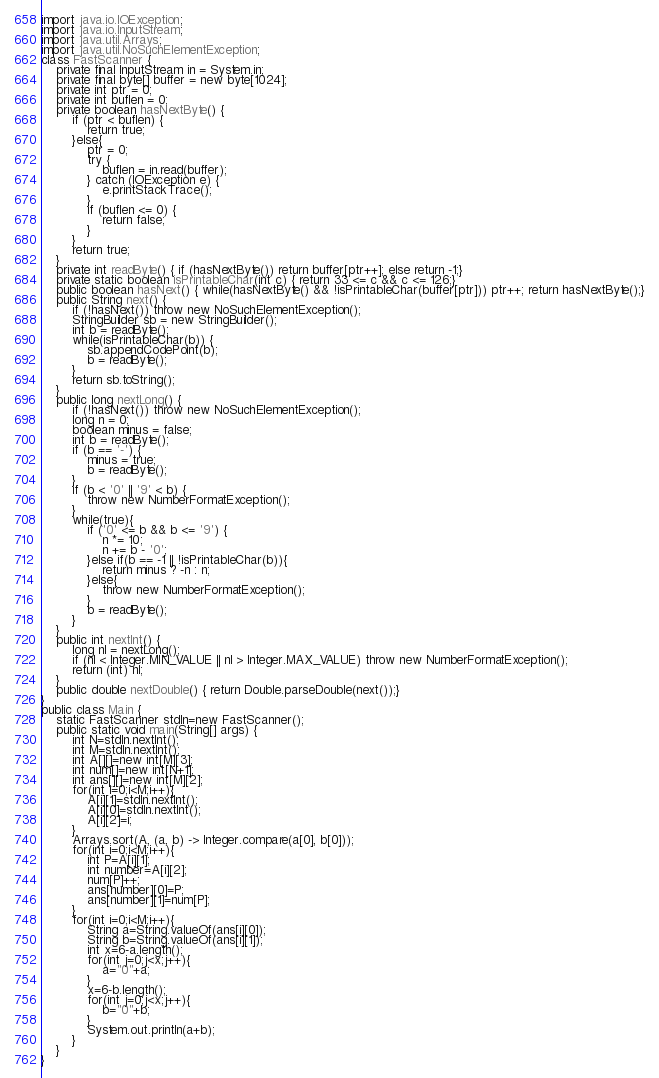<code> <loc_0><loc_0><loc_500><loc_500><_Java_>import java.io.IOException;
import java.io.InputStream;
import java.util.Arrays;
import java.util.NoSuchElementException;
class FastScanner {
    private final InputStream in = System.in;
    private final byte[] buffer = new byte[1024];
    private int ptr = 0;
    private int buflen = 0;
    private boolean hasNextByte() {
        if (ptr < buflen) {
            return true;
        }else{
            ptr = 0;
            try {
                buflen = in.read(buffer);
            } catch (IOException e) {
                e.printStackTrace();
            }
            if (buflen <= 0) {
                return false;
            }
        }
        return true;
    }
    private int readByte() { if (hasNextByte()) return buffer[ptr++]; else return -1;}
    private static boolean isPrintableChar(int c) { return 33 <= c && c <= 126;}
    public boolean hasNext() { while(hasNextByte() && !isPrintableChar(buffer[ptr])) ptr++; return hasNextByte();}
    public String next() {
        if (!hasNext()) throw new NoSuchElementException();
        StringBuilder sb = new StringBuilder();
        int b = readByte();
        while(isPrintableChar(b)) {
            sb.appendCodePoint(b);
            b = readByte();
        }
        return sb.toString();
    }
    public long nextLong() {
        if (!hasNext()) throw new NoSuchElementException();
        long n = 0;
        boolean minus = false;
        int b = readByte();
        if (b == '-') {
            minus = true;
            b = readByte();
        }
        if (b < '0' || '9' < b) {
            throw new NumberFormatException();
        }
        while(true){
            if ('0' <= b && b <= '9') {
                n *= 10;
                n += b - '0';
            }else if(b == -1 || !isPrintableChar(b)){
                return minus ? -n : n;
            }else{
                throw new NumberFormatException();
            }
            b = readByte();
        }
    }
    public int nextInt() {
        long nl = nextLong();
        if (nl < Integer.MIN_VALUE || nl > Integer.MAX_VALUE) throw new NumberFormatException();
        return (int) nl;
    }
    public double nextDouble() { return Double.parseDouble(next());}
}
public class Main {
	static FastScanner stdIn=new FastScanner();
	public static void main(String[] args) {
		int N=stdIn.nextInt();
		int M=stdIn.nextInt();
		int A[][]=new int[M][3];
		int num[]=new int[N+1];
		int ans[][]=new int[M][2];
		for(int i=0;i<M;i++){
			A[i][1]=stdIn.nextInt();
			A[i][0]=stdIn.nextInt();
			A[i][2]=i;
		}
		Arrays.sort(A, (a, b) -> Integer.compare(a[0], b[0]));
		for(int i=0;i<M;i++){
			int P=A[i][1];
			int number=A[i][2];
			num[P]++;
			ans[number][0]=P;
			ans[number][1]=num[P];
		}
		for(int i=0;i<M;i++){
			String a=String.valueOf(ans[i][0]);
			String b=String.valueOf(ans[i][1]);
			int x=6-a.length();
			for(int j=0;j<x;j++){
				a="0"+a;
			}
			x=6-b.length();
			for(int j=0;j<x;j++){
				b="0"+b;
			}
			System.out.println(a+b);
		}
	}
}
</code> 